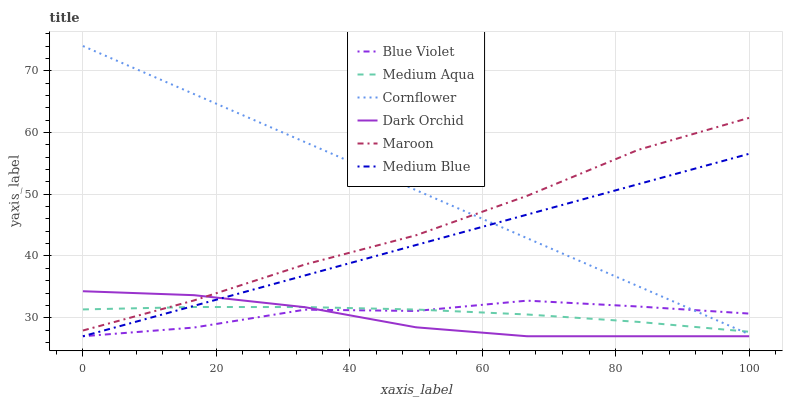Does Medium Blue have the minimum area under the curve?
Answer yes or no. No. Does Medium Blue have the maximum area under the curve?
Answer yes or no. No. Is Maroon the smoothest?
Answer yes or no. No. Is Maroon the roughest?
Answer yes or no. No. Does Maroon have the lowest value?
Answer yes or no. No. Does Medium Blue have the highest value?
Answer yes or no. No. Is Medium Blue less than Maroon?
Answer yes or no. Yes. Is Maroon greater than Blue Violet?
Answer yes or no. Yes. Does Medium Blue intersect Maroon?
Answer yes or no. No. 